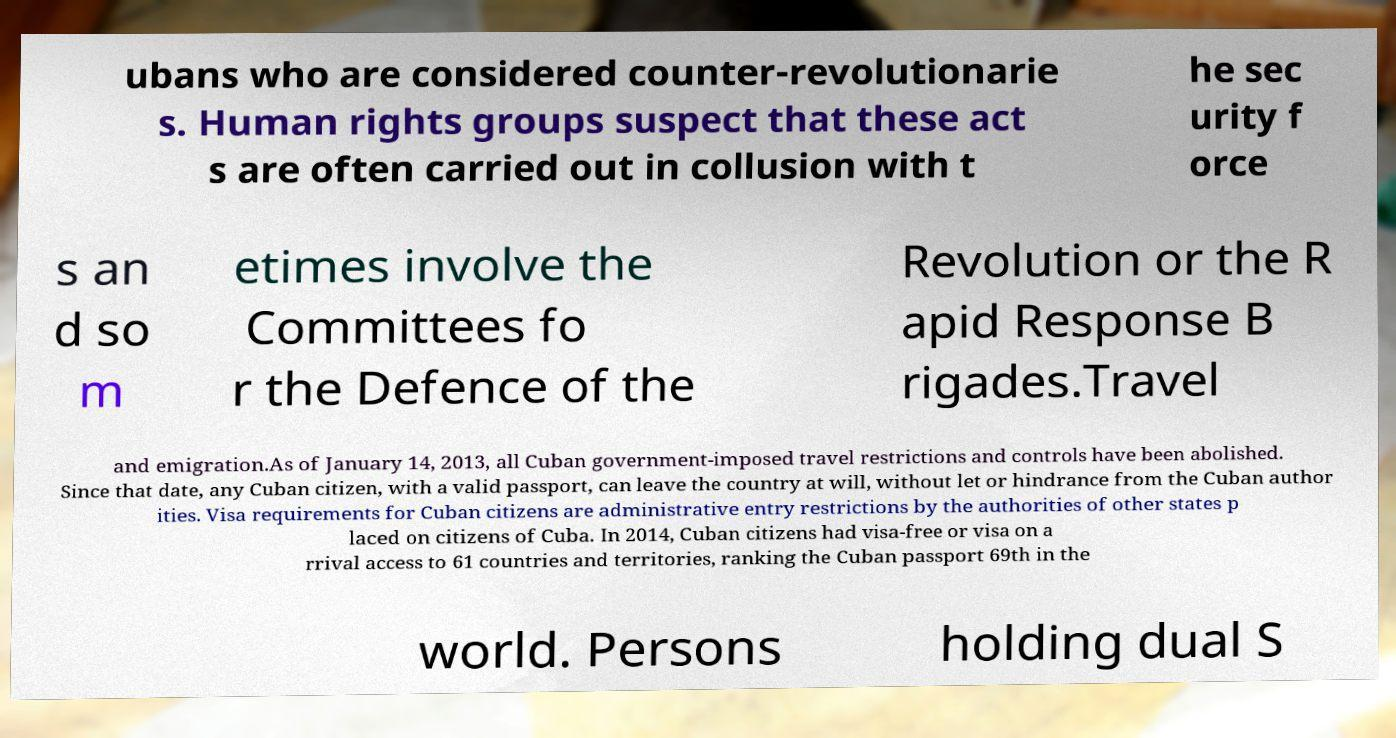Please read and relay the text visible in this image. What does it say? ubans who are considered counter-revolutionarie s. Human rights groups suspect that these act s are often carried out in collusion with t he sec urity f orce s an d so m etimes involve the Committees fo r the Defence of the Revolution or the R apid Response B rigades.Travel and emigration.As of January 14, 2013, all Cuban government-imposed travel restrictions and controls have been abolished. Since that date, any Cuban citizen, with a valid passport, can leave the country at will, without let or hindrance from the Cuban author ities. Visa requirements for Cuban citizens are administrative entry restrictions by the authorities of other states p laced on citizens of Cuba. In 2014, Cuban citizens had visa-free or visa on a rrival access to 61 countries and territories, ranking the Cuban passport 69th in the world. Persons holding dual S 